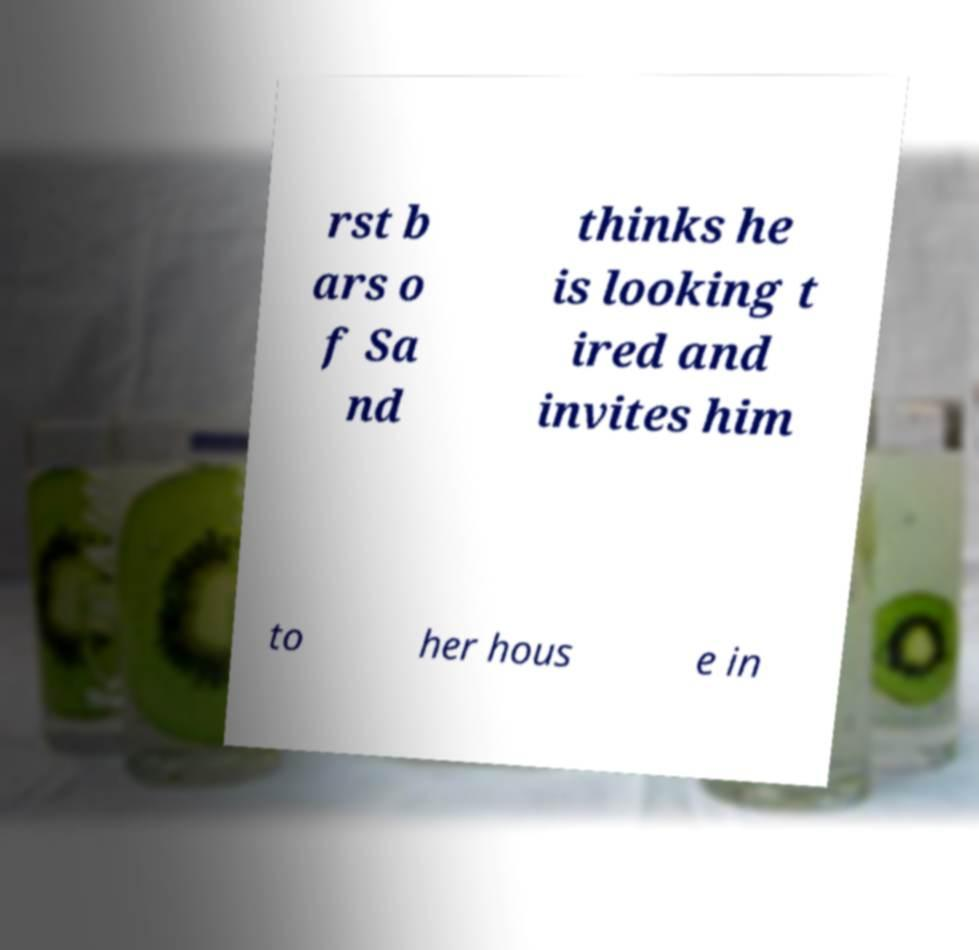I need the written content from this picture converted into text. Can you do that? rst b ars o f Sa nd thinks he is looking t ired and invites him to her hous e in 